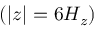<formula> <loc_0><loc_0><loc_500><loc_500>( | z | = 6 H _ { z } )</formula> 